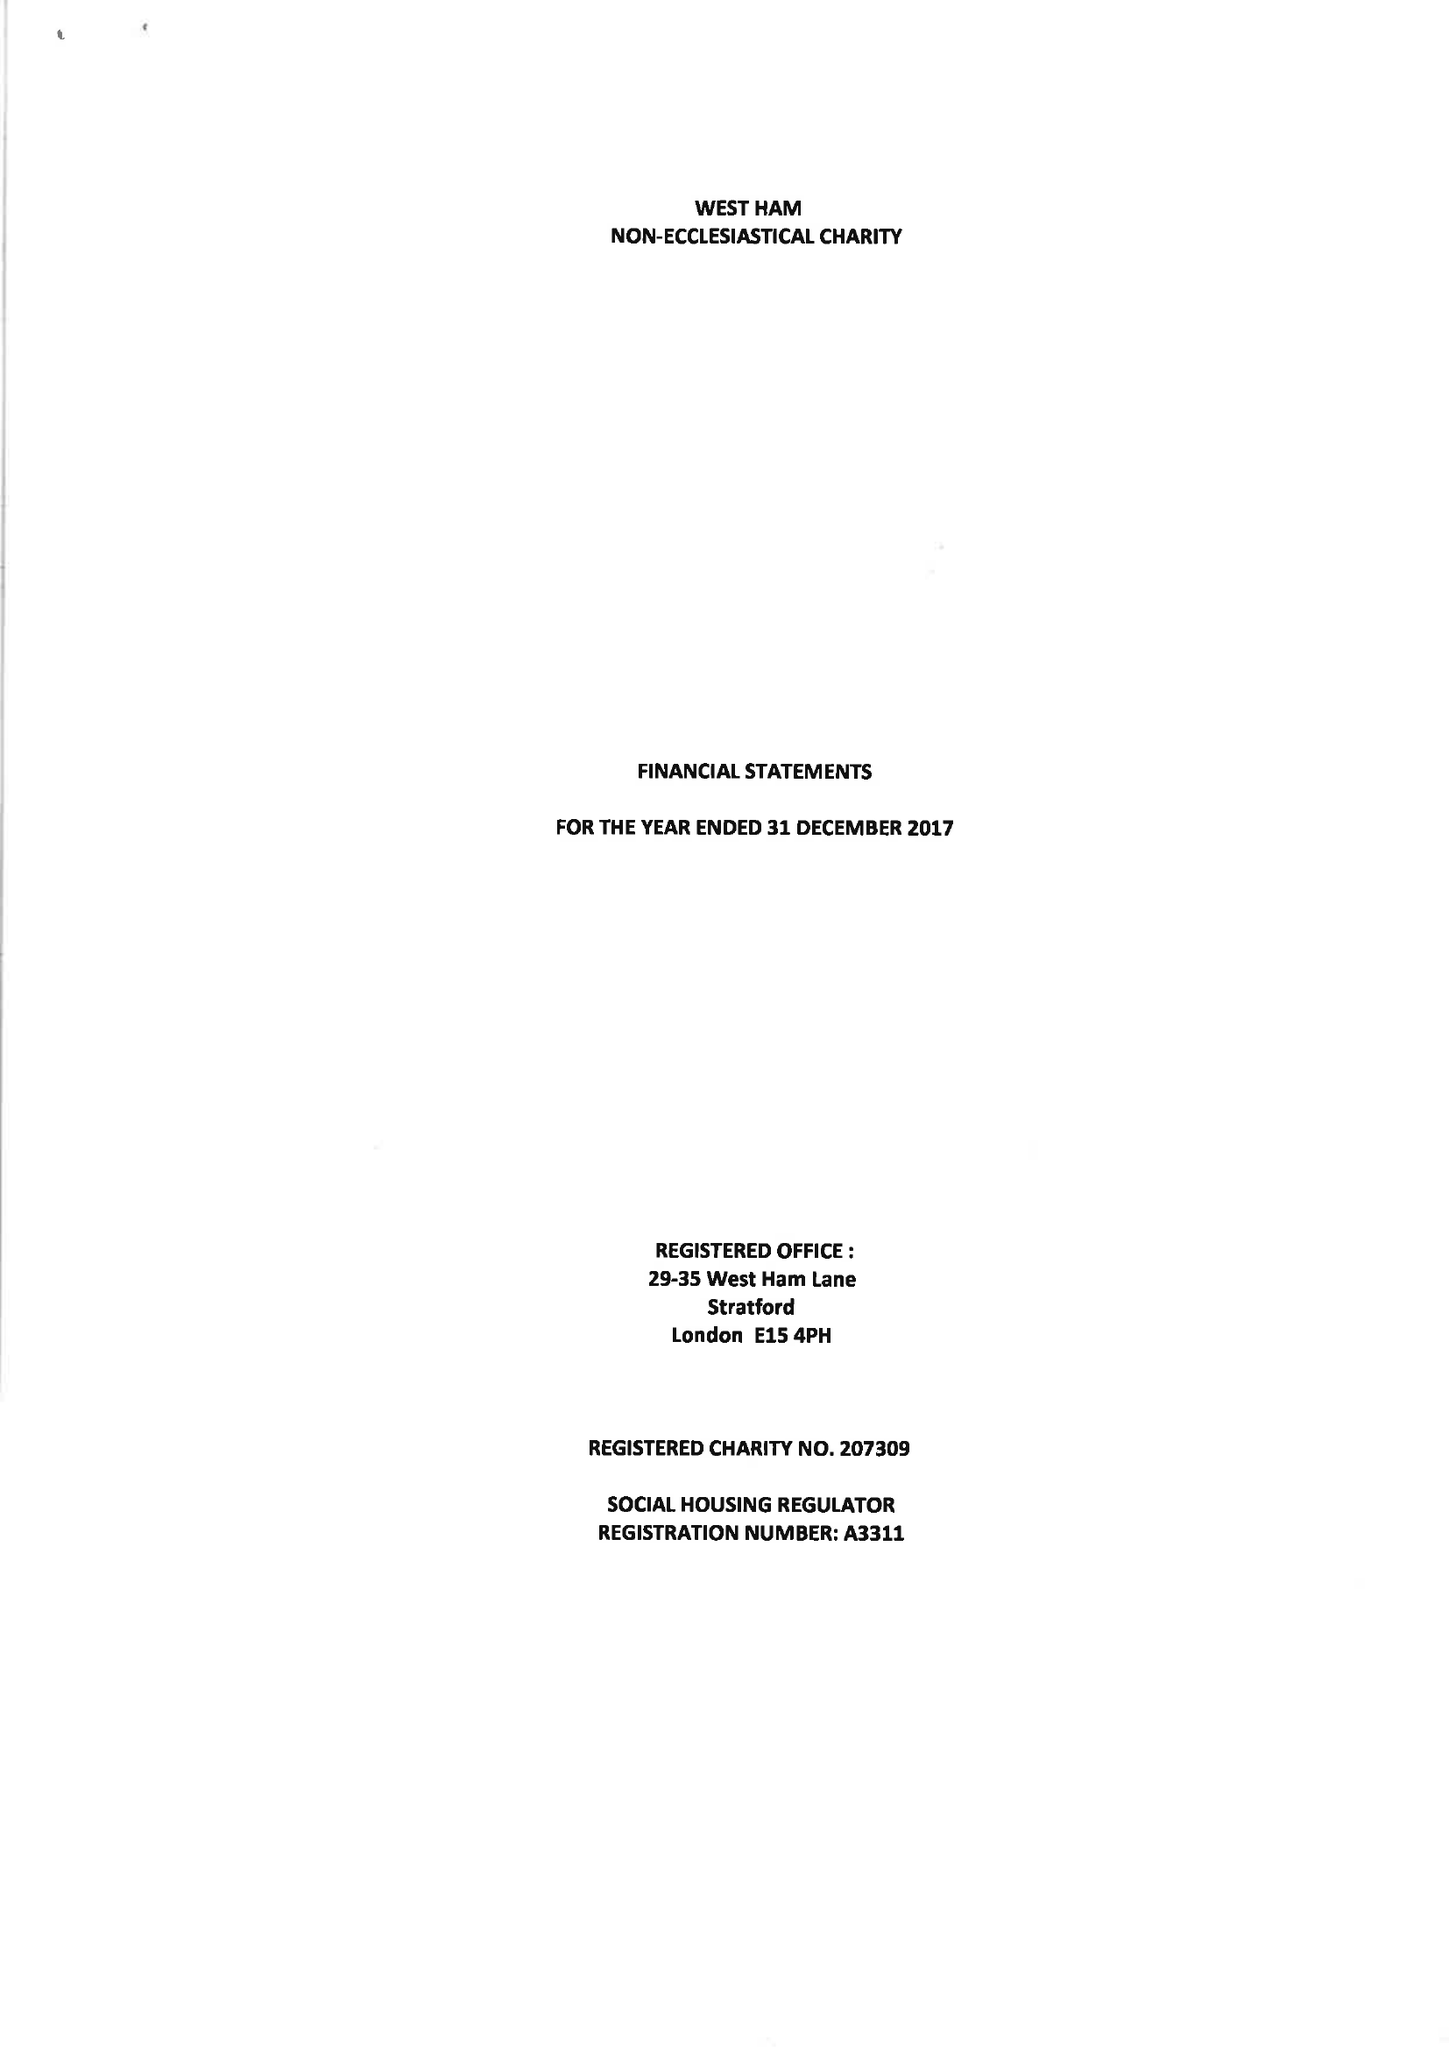What is the value for the address__street_line?
Answer the question using a single word or phrase. 29-35 WEST HAM LANE 